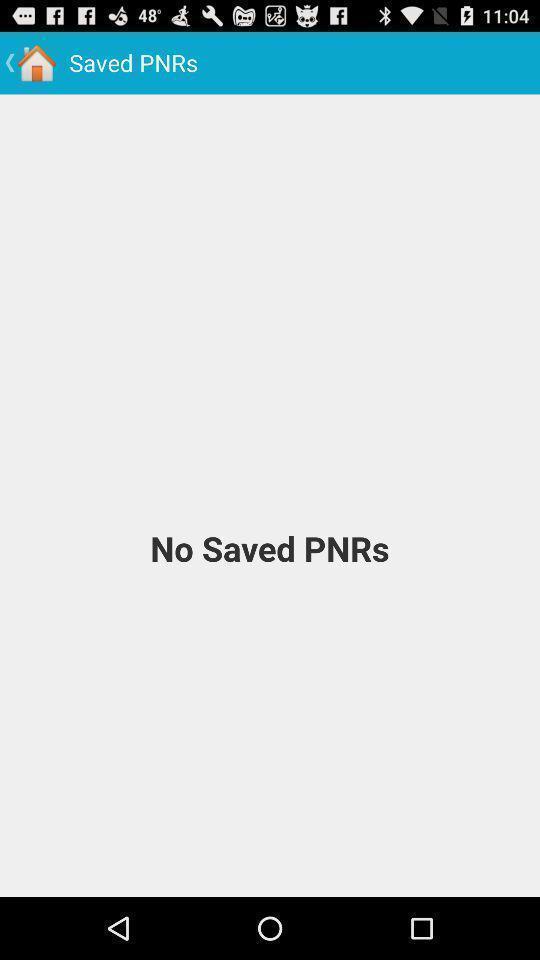Describe this image in words. Display shows saved pnrs page in railway app. 